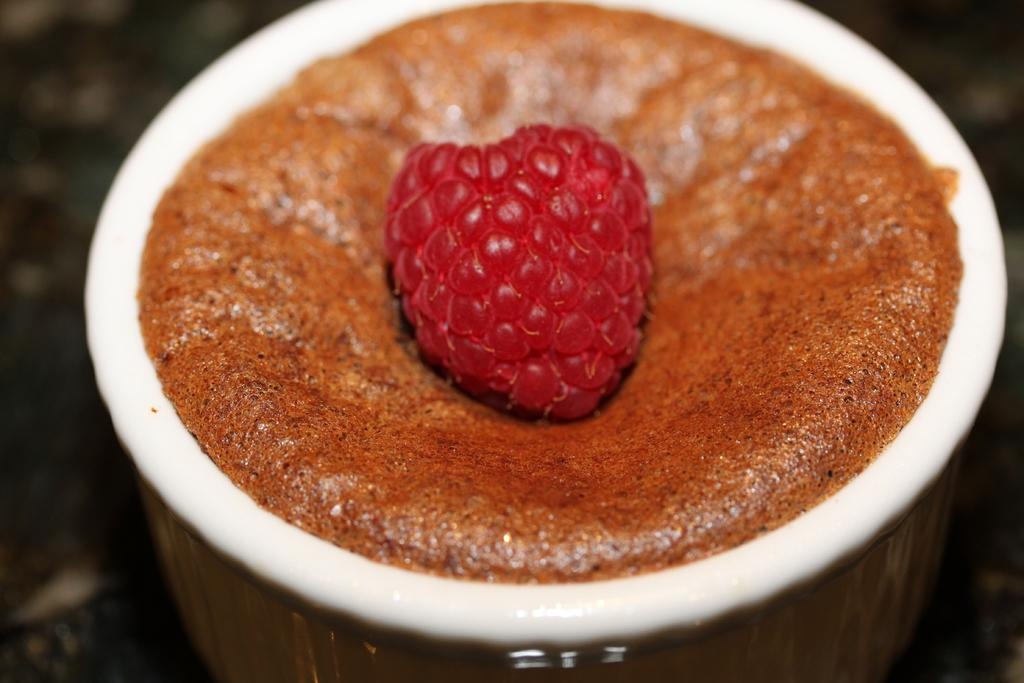What can be seen in the image? There is food in the image. Can you describe the background of the image? The background of the image is blurry. What type of card is being used to plant seeds in the image? There is no card or seeds present in the image; it only features food. Who is the expert in the image? There is no expert present in the image; it only features food and a blurry background. 